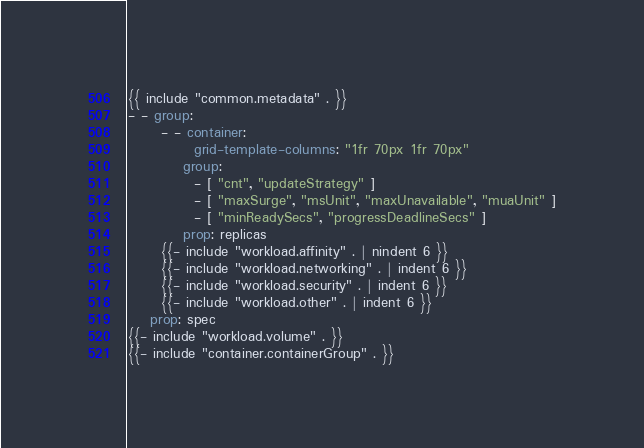<code> <loc_0><loc_0><loc_500><loc_500><_YAML_>{{ include "common.metadata" . }}
- - group:
      - - container:
            grid-template-columns: "1fr 70px 1fr 70px"
          group:
            - [ "cnt", "updateStrategy" ]
            - [ "maxSurge", "msUnit", "maxUnavailable", "muaUnit" ]
            - [ "minReadySecs", "progressDeadlineSecs" ]
          prop: replicas
      {{- include "workload.affinity" . | nindent 6 }}
      {{- include "workload.networking" . | indent 6 }}
      {{- include "workload.security" . | indent 6 }}
      {{- include "workload.other" . | indent 6 }}
    prop: spec
{{- include "workload.volume" . }}
{{- include "container.containerGroup" . }}
</code> 